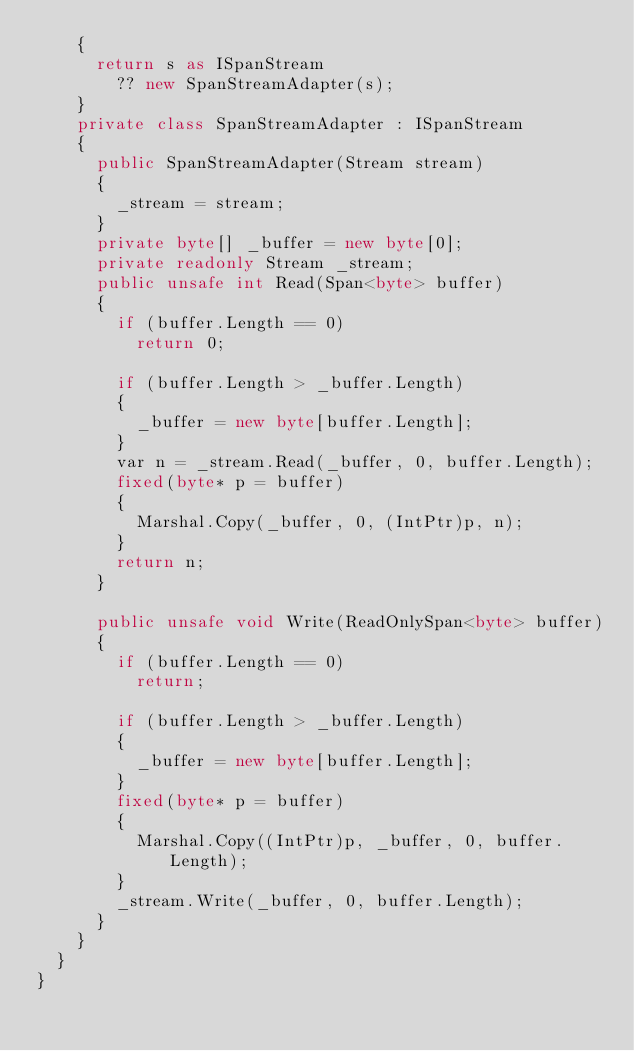<code> <loc_0><loc_0><loc_500><loc_500><_C#_>		{
			return s as ISpanStream
				?? new SpanStreamAdapter(s);
		}
		private class SpanStreamAdapter : ISpanStream
		{
			public SpanStreamAdapter(Stream stream)
			{
				_stream = stream;
			}
			private byte[] _buffer = new byte[0];
			private readonly Stream _stream;
			public unsafe int Read(Span<byte> buffer)
			{
				if (buffer.Length == 0)
					return 0;

				if (buffer.Length > _buffer.Length)
				{
					_buffer = new byte[buffer.Length];
				}
				var n = _stream.Read(_buffer, 0, buffer.Length);
				fixed(byte* p = buffer)
				{
					Marshal.Copy(_buffer, 0, (IntPtr)p, n);
				}
				return n;
			}

			public unsafe void Write(ReadOnlySpan<byte> buffer)
			{
				if (buffer.Length == 0)
					return;

				if (buffer.Length > _buffer.Length)
				{
					_buffer = new byte[buffer.Length];
				}
				fixed(byte* p = buffer)
				{
					Marshal.Copy((IntPtr)p, _buffer, 0, buffer.Length);
				}
				_stream.Write(_buffer, 0, buffer.Length);
			}
		}
	}
}
</code> 